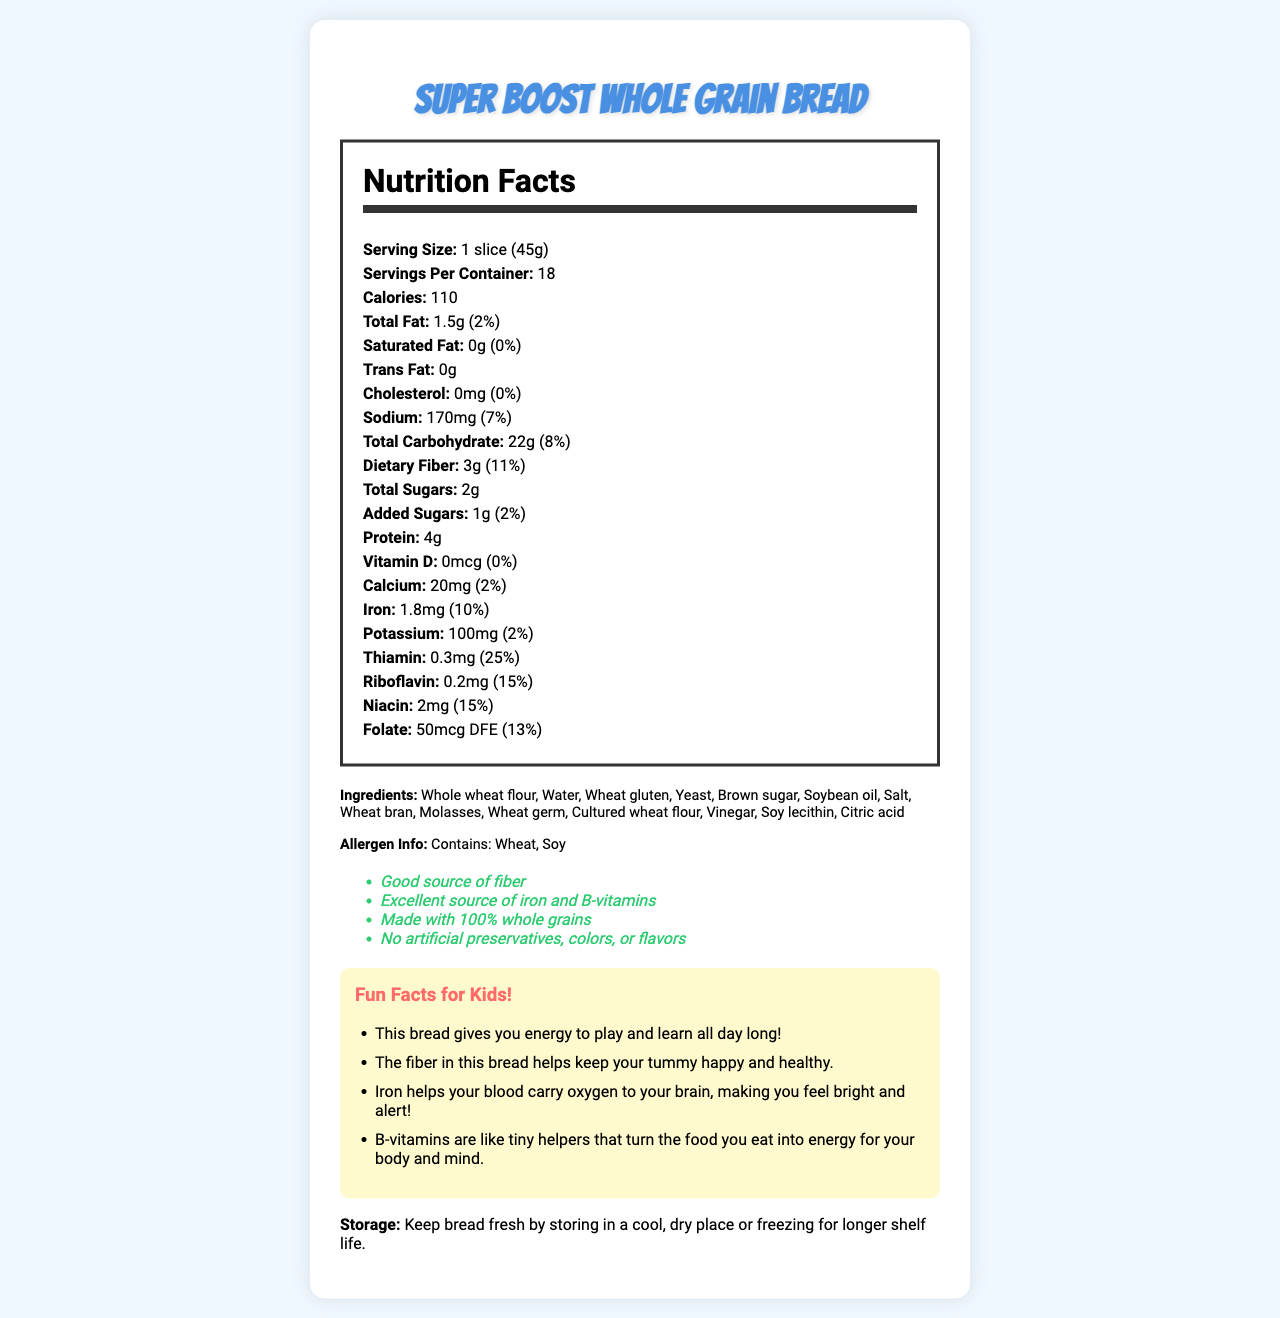what is the serving size of Super Boost Whole Grain Bread? The serving size is listed in the document as "1 slice (45g)".
Answer: 1 slice (45g) how many calories are in one serving of Super Boost Whole Grain Bread? The document specifies that there are 110 calories per serving.
Answer: 110 how much dietary fiber does one slice of this bread contain? According to the nutrition facts, one slice contains 3g of dietary fiber.
Answer: 3g which nutrients contribute to energy production in the Super Boost Whole Grain Bread? Carbohydrates and protein are primary sources of energy, and the B-vitamins are noted for helping convert food into energy.
Answer: Carbohydrates, protein, B-vitamins (thiamin, riboflavin, niacin, folate) how much iron is provided in a serving, and what is the daily value percentage? The nutrition label indicates that each serving contains 1.8mg of iron, which is 10% of the daily value.
Answer: 1.8mg, 10% what is the total fat content per serving of this bread? The document specifies that each serving contains 1.5g of total fat.
Answer: 1.5g how many servings are there per container? The serving information reveals that there are 18 servings in the container.
Answer: 18 which ingredient is listed first in the ingredients list, and why might this be important? Ingredients are typically listed in order of weight, so there is likely more whole wheat flour than any other ingredient.
Answer: Whole wheat flour what is not present in this bread, according to the nutrition facts? A. Saturated Fat B. Trans Fat C. Cholesterol D. All of the above The document shows that the bread has 0g of saturated fat, trans fat, and cholesterol.
Answer: D. All of the above how are the dietary fiber and kid-friendly facts related? A. Dietary fiber helps keep your tummy happy and healthy. B. Dietary fiber makes you sleepy. C. Dietary fiber increases energy levels. D. Dietary fiber makes hair grow faster. The kid-friendly fact states that dietary fiber helps keep your tummy happy and healthy.
Answer: A. Dietary fiber helps keep your tummy happy and healthy. is this bread suitable for people with gluten allergies? The bread contains wheat and wheat gluten, as well as a warning that it contains wheat and soy, making it unsuitable for people with gluten allergies.
Answer: No does this bread contain more protein or added sugars? The bread contains 4g of protein per serving and only 1g of added sugars.
Answer: Protein summarize the main features of Super Boost Whole Grain Bread. The bread's nutrition facts highlight its energy-providing nutrients, fiber, and essential vitamins and minerals. The additional kid-friendly facts and storage instructions help further describe its benefits and usage.
Answer: Super Boost Whole Grain Bread is a whole grain bread that provides sustained energy through its rich content of carbohydrates, protein, fiber, iron, and B-vitamins. It is noted for having no artificial preservatives, colors, or flavors, and it contains significant amounts of thiamin, riboflavin, niacin, and iron. It is also kid-friendly with benefits such as promoting energy, healthy digestion, and cognitive alertness. The bread must be stored in a cool, dry place or frozen for longer shelf life. what is the recommended storage method for Super Boost Whole Grain Bread? According to the storage instructions, the bread should be kept in a cool, dry place or frozen to extend its shelf life.
Answer: Keep bread fresh by storing in a cool, dry place or freezing for longer shelf life. how much sodium is in one serving of this bread? The nutrition facts list the sodium content as 170mg per serving.
Answer: 170mg does the bread contain any artificial preservatives, colors, or flavors? The health claims specifically state that the bread contains no artificial preservatives, colors, or flavors.
Answer: No which vitamin provides the highest daily value percentage per serving? The document indicates that thiamin provides 25% of the daily value per serving.
Answer: Thiamin what are the storage instructions for Super Boost Whole Grain Bread? The storage instructions are provided at the end of the document.
Answer: Keep bread fresh by storing in a cool, dry place or freezing for longer shelf life. what type of flour is used in this bread? The ingredients list specifies that whole wheat flour is used.
Answer: Whole wheat flour 